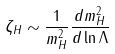<formula> <loc_0><loc_0><loc_500><loc_500>\zeta _ { H } \sim \frac { 1 } { m _ { H } ^ { 2 } } \frac { d m _ { H } ^ { 2 } } { d \ln \Lambda }</formula> 